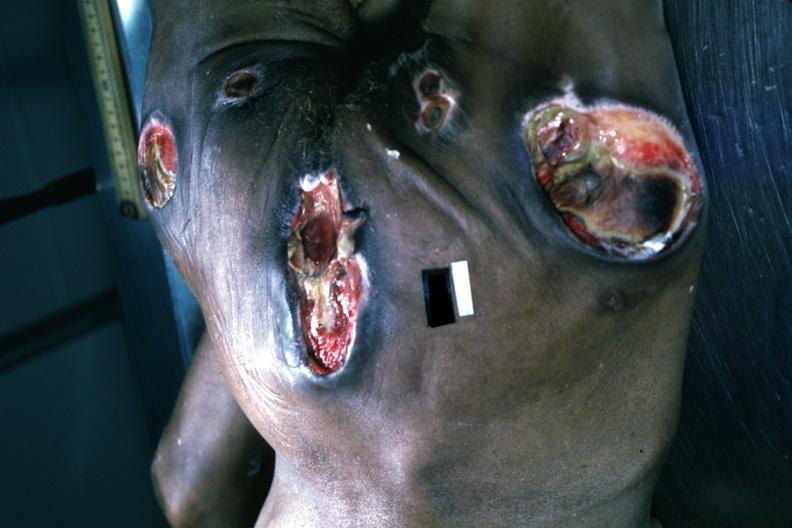where is this?
Answer the question using a single word or phrase. Skin 